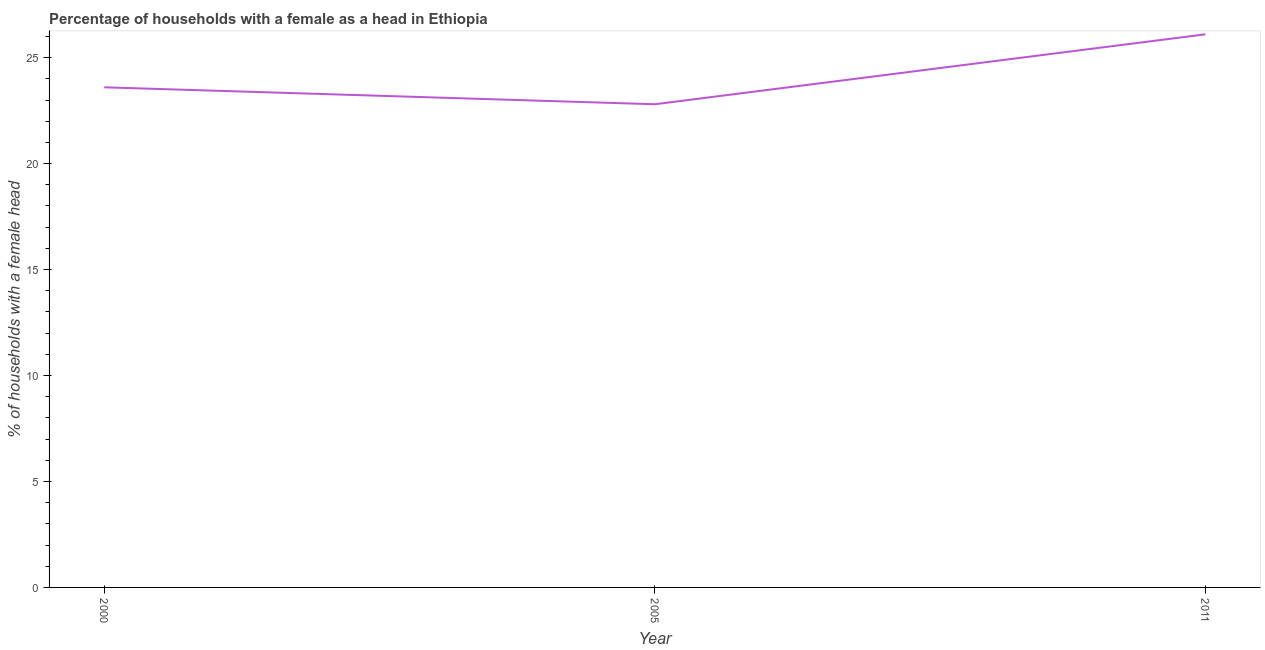What is the number of female supervised households in 2005?
Offer a terse response. 22.8. Across all years, what is the maximum number of female supervised households?
Your response must be concise. 26.1. Across all years, what is the minimum number of female supervised households?
Give a very brief answer. 22.8. What is the sum of the number of female supervised households?
Give a very brief answer. 72.5. What is the difference between the number of female supervised households in 2005 and 2011?
Provide a succinct answer. -3.3. What is the average number of female supervised households per year?
Offer a very short reply. 24.17. What is the median number of female supervised households?
Make the answer very short. 23.6. What is the ratio of the number of female supervised households in 2000 to that in 2005?
Ensure brevity in your answer.  1.04. Is the number of female supervised households in 2000 less than that in 2011?
Offer a very short reply. Yes. Is the difference between the number of female supervised households in 2000 and 2005 greater than the difference between any two years?
Provide a short and direct response. No. Is the sum of the number of female supervised households in 2005 and 2011 greater than the maximum number of female supervised households across all years?
Provide a short and direct response. Yes. What is the difference between the highest and the lowest number of female supervised households?
Offer a very short reply. 3.3. Does the number of female supervised households monotonically increase over the years?
Your response must be concise. No. What is the difference between two consecutive major ticks on the Y-axis?
Keep it short and to the point. 5. Are the values on the major ticks of Y-axis written in scientific E-notation?
Provide a succinct answer. No. Does the graph contain grids?
Offer a very short reply. No. What is the title of the graph?
Provide a short and direct response. Percentage of households with a female as a head in Ethiopia. What is the label or title of the Y-axis?
Make the answer very short. % of households with a female head. What is the % of households with a female head of 2000?
Your answer should be compact. 23.6. What is the % of households with a female head of 2005?
Ensure brevity in your answer.  22.8. What is the % of households with a female head in 2011?
Keep it short and to the point. 26.1. What is the difference between the % of households with a female head in 2000 and 2005?
Ensure brevity in your answer.  0.8. What is the difference between the % of households with a female head in 2000 and 2011?
Offer a very short reply. -2.5. What is the ratio of the % of households with a female head in 2000 to that in 2005?
Provide a short and direct response. 1.03. What is the ratio of the % of households with a female head in 2000 to that in 2011?
Offer a terse response. 0.9. What is the ratio of the % of households with a female head in 2005 to that in 2011?
Provide a succinct answer. 0.87. 